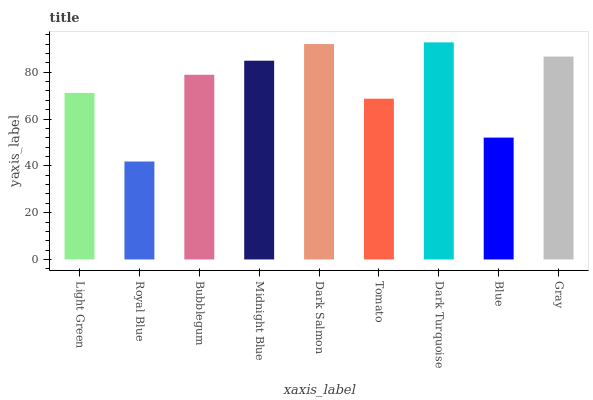Is Royal Blue the minimum?
Answer yes or no. Yes. Is Dark Turquoise the maximum?
Answer yes or no. Yes. Is Bubblegum the minimum?
Answer yes or no. No. Is Bubblegum the maximum?
Answer yes or no. No. Is Bubblegum greater than Royal Blue?
Answer yes or no. Yes. Is Royal Blue less than Bubblegum?
Answer yes or no. Yes. Is Royal Blue greater than Bubblegum?
Answer yes or no. No. Is Bubblegum less than Royal Blue?
Answer yes or no. No. Is Bubblegum the high median?
Answer yes or no. Yes. Is Bubblegum the low median?
Answer yes or no. Yes. Is Royal Blue the high median?
Answer yes or no. No. Is Blue the low median?
Answer yes or no. No. 